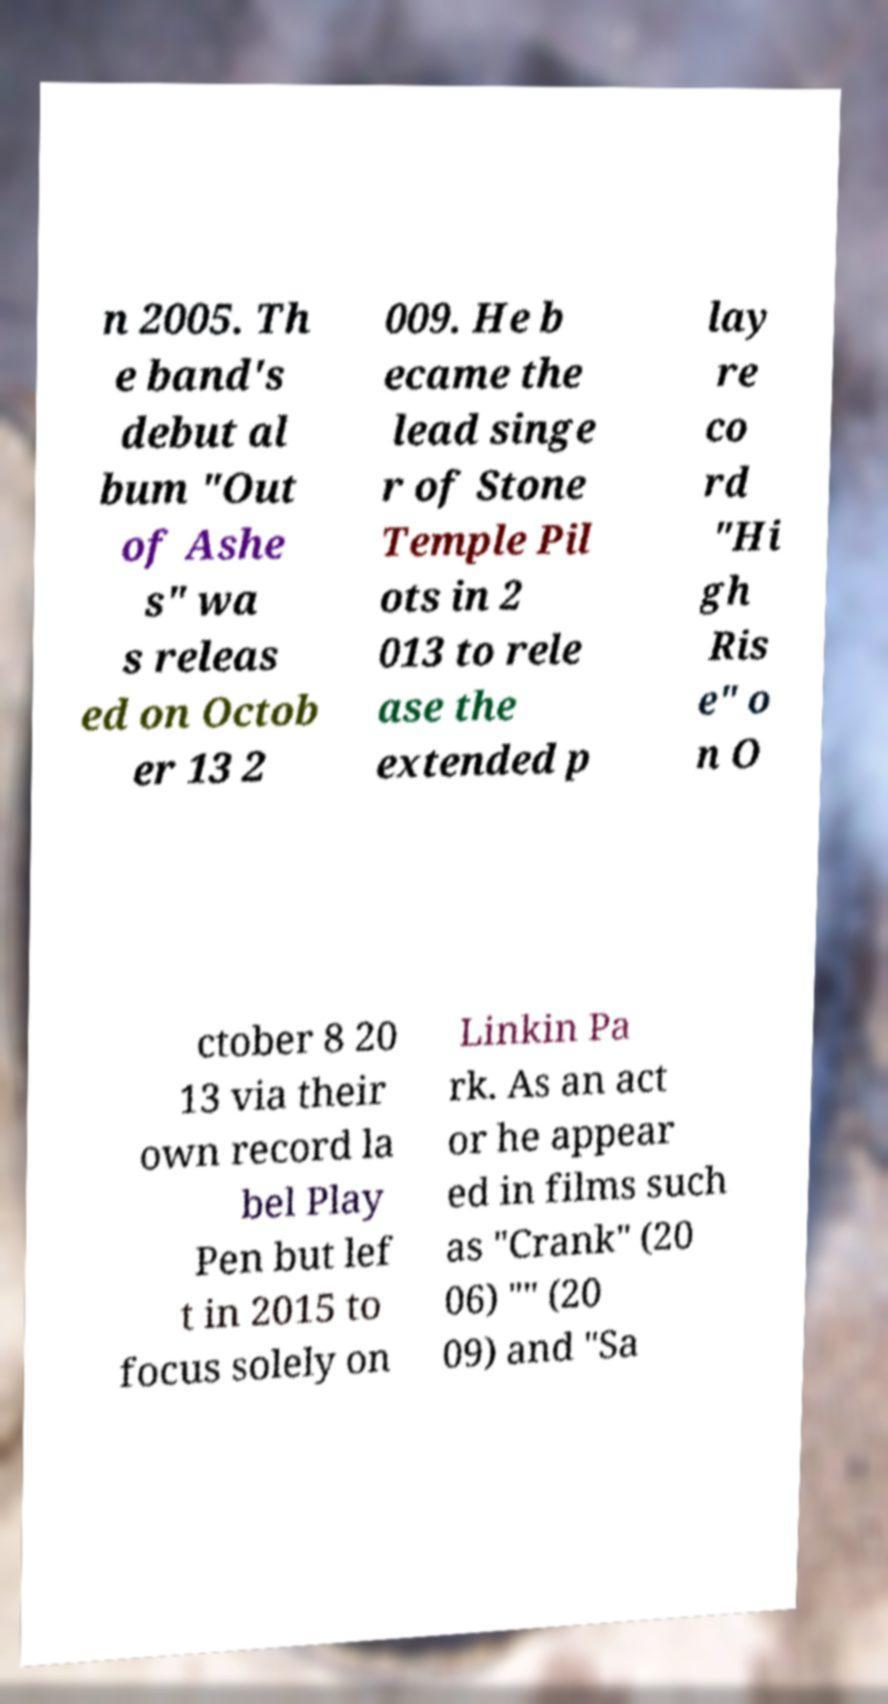Please identify and transcribe the text found in this image. n 2005. Th e band's debut al bum "Out of Ashe s" wa s releas ed on Octob er 13 2 009. He b ecame the lead singe r of Stone Temple Pil ots in 2 013 to rele ase the extended p lay re co rd "Hi gh Ris e" o n O ctober 8 20 13 via their own record la bel Play Pen but lef t in 2015 to focus solely on Linkin Pa rk. As an act or he appear ed in films such as "Crank" (20 06) "" (20 09) and "Sa 